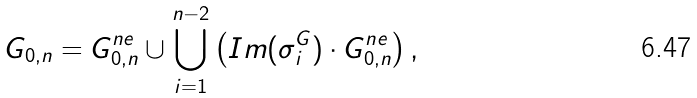<formula> <loc_0><loc_0><loc_500><loc_500>G _ { 0 , n } = G _ { 0 , n } ^ { n e } \cup \bigcup _ { i = 1 } ^ { n - 2 } \left ( I m ( \sigma ^ { G } _ { i } ) \cdot G _ { 0 , n } ^ { n e } \right ) ,</formula> 